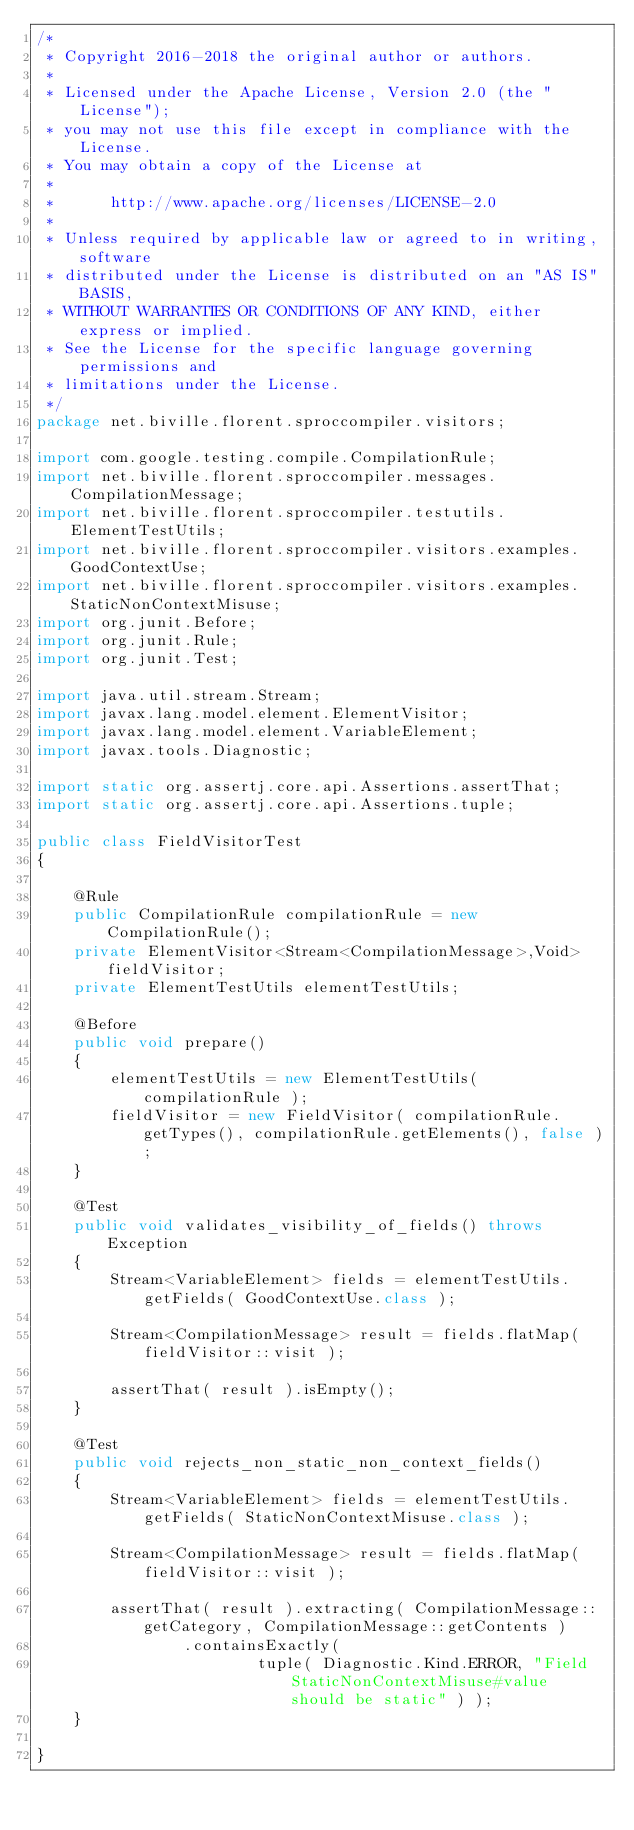Convert code to text. <code><loc_0><loc_0><loc_500><loc_500><_Java_>/*
 * Copyright 2016-2018 the original author or authors.
 *
 * Licensed under the Apache License, Version 2.0 (the "License");
 * you may not use this file except in compliance with the License.
 * You may obtain a copy of the License at
 *
 *      http://www.apache.org/licenses/LICENSE-2.0
 *
 * Unless required by applicable law or agreed to in writing, software
 * distributed under the License is distributed on an "AS IS" BASIS,
 * WITHOUT WARRANTIES OR CONDITIONS OF ANY KIND, either express or implied.
 * See the License for the specific language governing permissions and
 * limitations under the License.
 */
package net.biville.florent.sproccompiler.visitors;

import com.google.testing.compile.CompilationRule;
import net.biville.florent.sproccompiler.messages.CompilationMessage;
import net.biville.florent.sproccompiler.testutils.ElementTestUtils;
import net.biville.florent.sproccompiler.visitors.examples.GoodContextUse;
import net.biville.florent.sproccompiler.visitors.examples.StaticNonContextMisuse;
import org.junit.Before;
import org.junit.Rule;
import org.junit.Test;

import java.util.stream.Stream;
import javax.lang.model.element.ElementVisitor;
import javax.lang.model.element.VariableElement;
import javax.tools.Diagnostic;

import static org.assertj.core.api.Assertions.assertThat;
import static org.assertj.core.api.Assertions.tuple;

public class FieldVisitorTest
{

    @Rule
    public CompilationRule compilationRule = new CompilationRule();
    private ElementVisitor<Stream<CompilationMessage>,Void> fieldVisitor;
    private ElementTestUtils elementTestUtils;

    @Before
    public void prepare()
    {
        elementTestUtils = new ElementTestUtils( compilationRule );
        fieldVisitor = new FieldVisitor( compilationRule.getTypes(), compilationRule.getElements(), false );
    }

    @Test
    public void validates_visibility_of_fields() throws Exception
    {
        Stream<VariableElement> fields = elementTestUtils.getFields( GoodContextUse.class );

        Stream<CompilationMessage> result = fields.flatMap( fieldVisitor::visit );

        assertThat( result ).isEmpty();
    }

    @Test
    public void rejects_non_static_non_context_fields()
    {
        Stream<VariableElement> fields = elementTestUtils.getFields( StaticNonContextMisuse.class );

        Stream<CompilationMessage> result = fields.flatMap( fieldVisitor::visit );

        assertThat( result ).extracting( CompilationMessage::getCategory, CompilationMessage::getContents )
                .containsExactly(
                        tuple( Diagnostic.Kind.ERROR, "Field StaticNonContextMisuse#value should be static" ) );
    }

}

</code> 